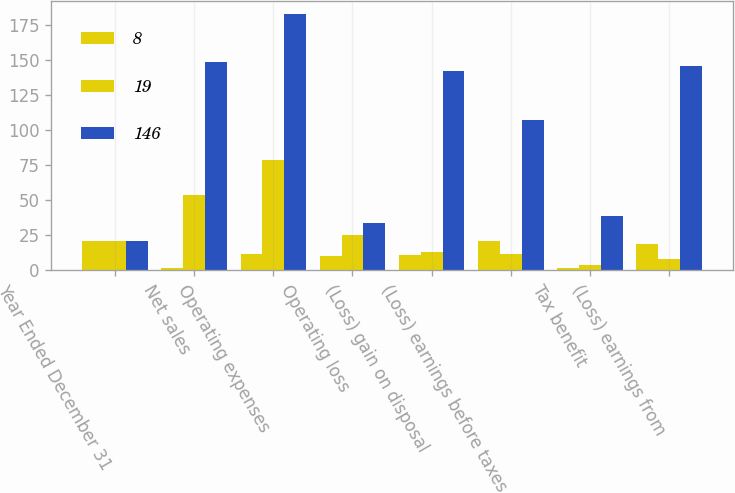Convert chart. <chart><loc_0><loc_0><loc_500><loc_500><stacked_bar_chart><ecel><fcel>Year Ended December 31<fcel>Net sales<fcel>Operating expenses<fcel>Operating loss<fcel>(Loss) gain on disposal<fcel>(Loss) earnings before taxes<fcel>Tax benefit<fcel>(Loss) earnings from<nl><fcel>8<fcel>21<fcel>2<fcel>12<fcel>10<fcel>11<fcel>21<fcel>2<fcel>19<nl><fcel>19<fcel>21<fcel>54<fcel>79<fcel>25<fcel>13<fcel>12<fcel>4<fcel>8<nl><fcel>146<fcel>21<fcel>149<fcel>183<fcel>34<fcel>142<fcel>107<fcel>39<fcel>146<nl></chart> 